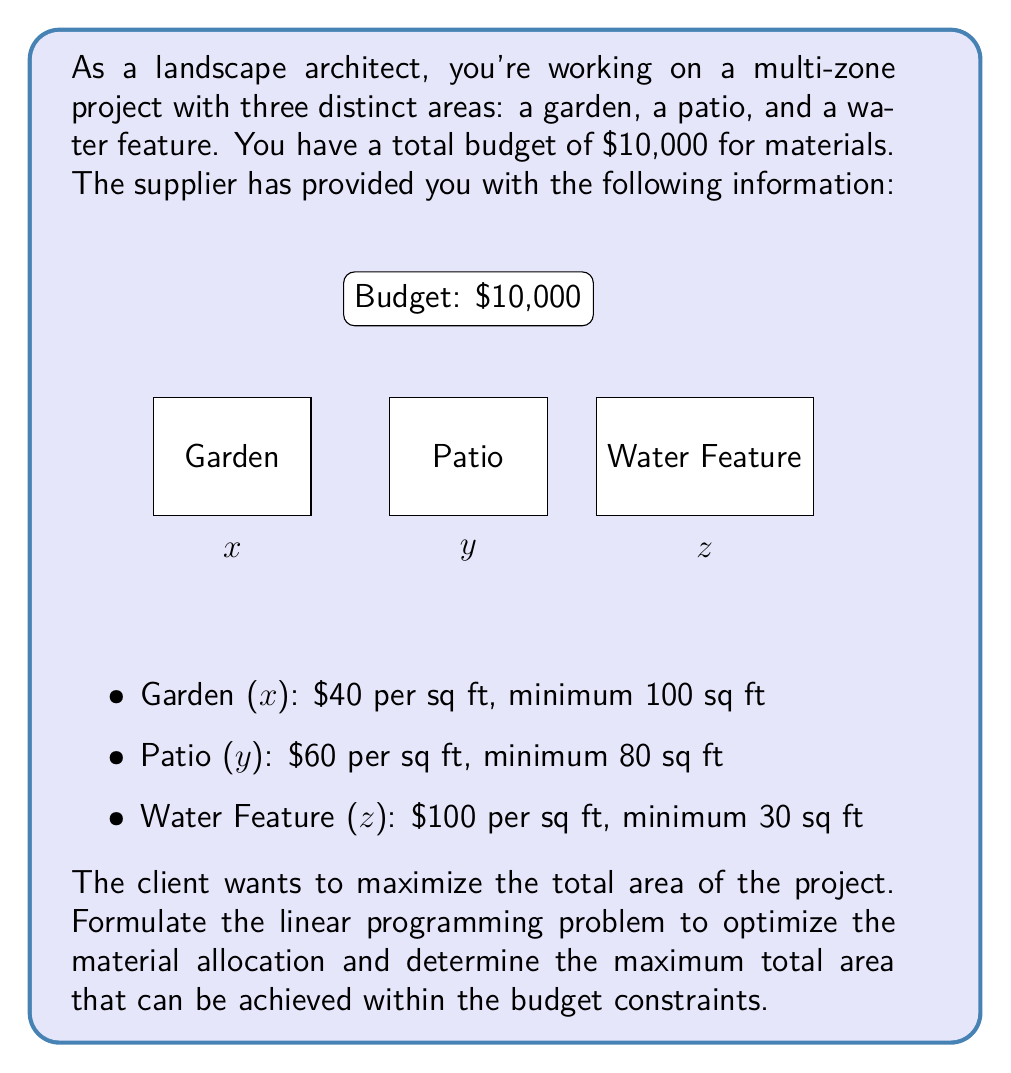Teach me how to tackle this problem. To solve this linear programming problem, we'll follow these steps:

1. Define the variables:
   x = area of the garden (sq ft)
   y = area of the patio (sq ft)
   z = area of the water feature (sq ft)

2. Formulate the objective function:
   Maximize: $f(x,y,z) = x + y + z$

3. Identify the constraints:
   a) Budget constraint: $40x + 60y + 100z \leq 10000$
   b) Minimum area constraints:
      x ≥ 100
      y ≥ 80
      z ≥ 30
   c) Non-negativity constraints:
      x, y, z ≥ 0

4. Write the complete linear programming problem:

   Maximize: $f(x,y,z) = x + y + z$
   Subject to:
   $40x + 60y + 100z \leq 10000$
   $x \geq 100$
   $y \geq 80$
   $z \geq 30$
   $x, y, z \geq 0$

5. Solve the problem using the simplex method or linear programming software.

The solution to this problem would give us the optimal allocation of materials for each zone, maximizing the total area within the given constraints.
Answer: Maximize: $f(x,y,z) = x + y + z$
Subject to:
$40x + 60y + 100z \leq 10000$
$x \geq 100$, $y \geq 80$, $z \geq 30$
$x, y, z \geq 0$ 